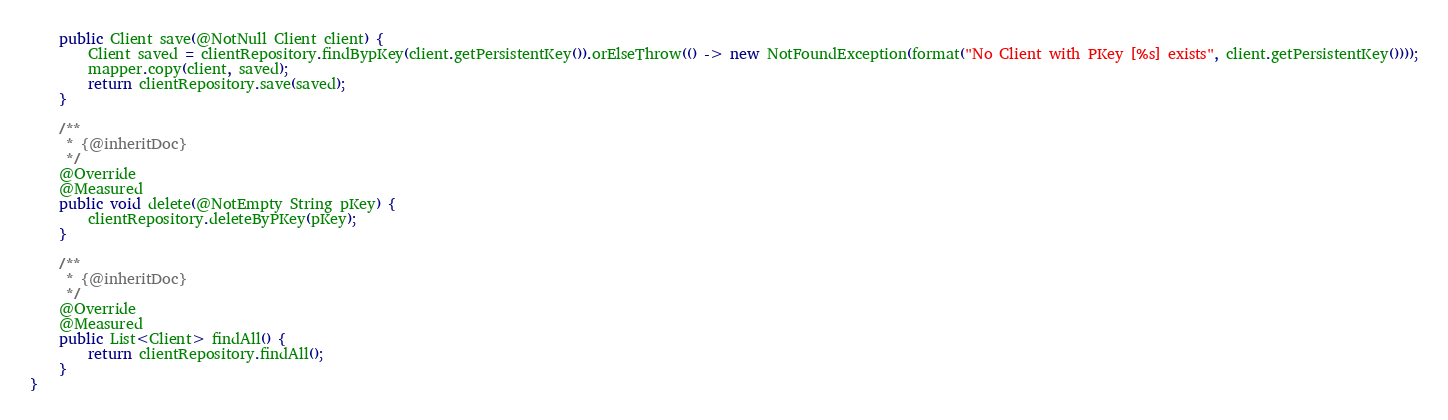<code> <loc_0><loc_0><loc_500><loc_500><_Java_>    public Client save(@NotNull Client client) {
        Client saved = clientRepository.findBypKey(client.getPersistentKey()).orElseThrow(() -> new NotFoundException(format("No Client with PKey [%s] exists", client.getPersistentKey())));
        mapper.copy(client, saved);
        return clientRepository.save(saved);
    }

    /**
     * {@inheritDoc}
     */
    @Override
    @Measured
    public void delete(@NotEmpty String pKey) {
        clientRepository.deleteByPKey(pKey);
    }

    /**
     * {@inheritDoc}
     */
    @Override
    @Measured
    public List<Client> findAll() {
        return clientRepository.findAll();
    }
}
</code> 